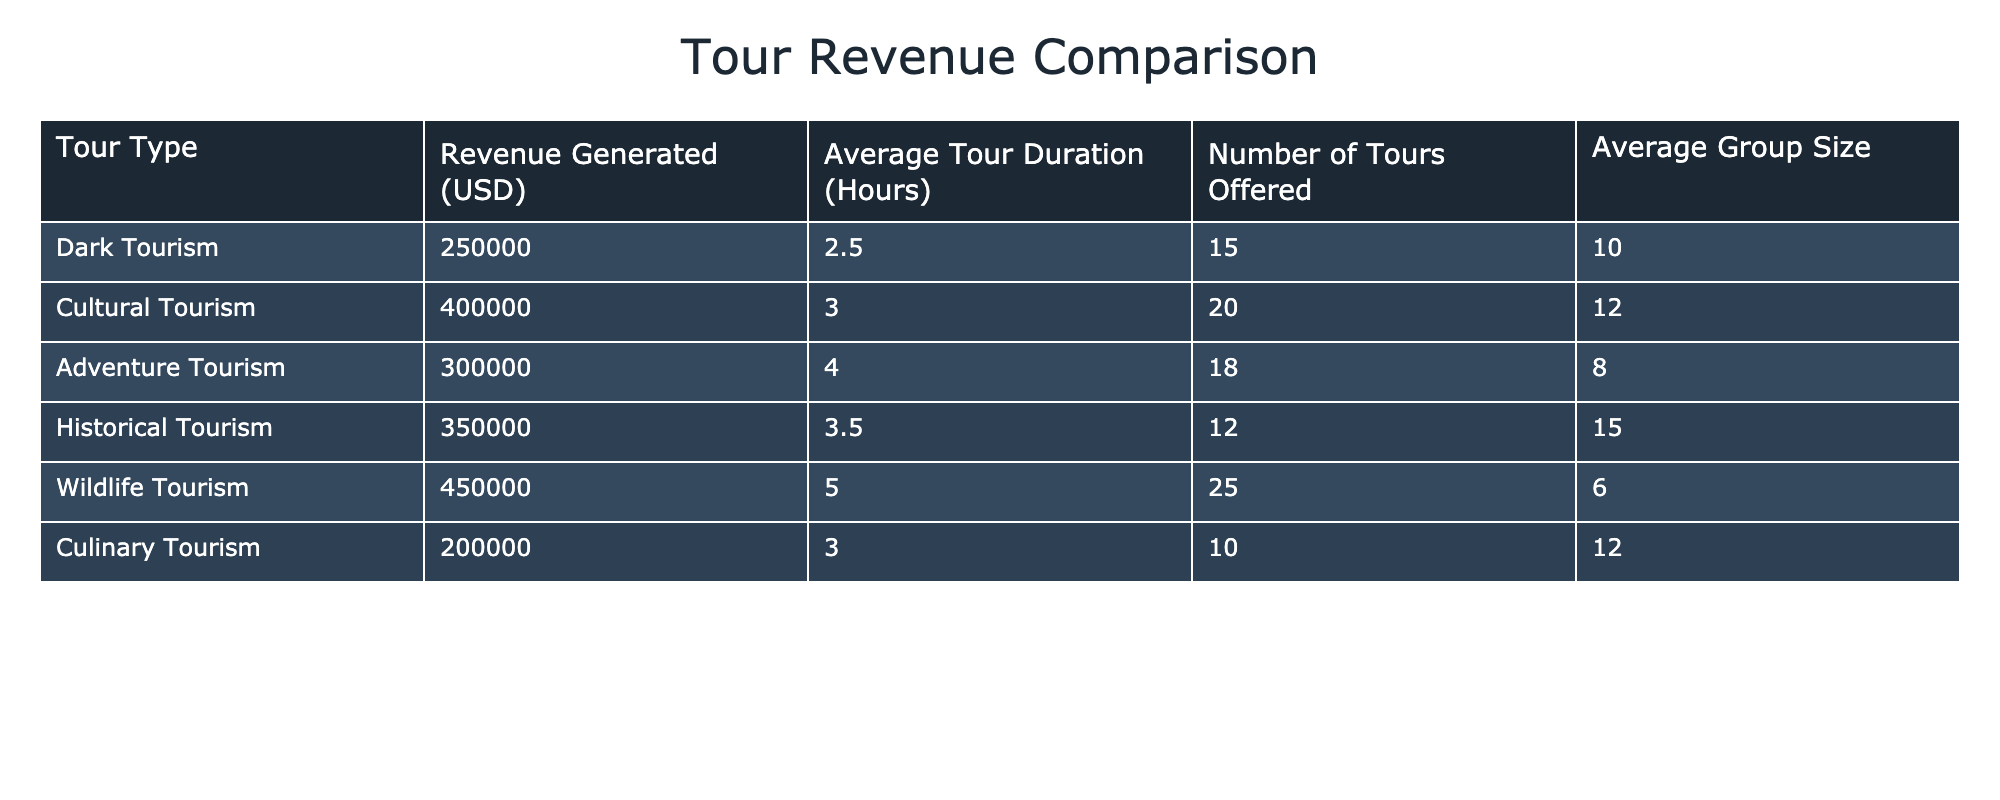What is the revenue generated from dark tourism tours? The table shows that the revenue generated from dark tourism tours is listed as 250000 USD.
Answer: 250000 USD How many tours are offered for cultural tourism? From the table, the number of tours offered for cultural tourism is clearly stated as 20.
Answer: 20 Which type of tourism has the highest average group size? By comparing the average group sizes from each type of tourism, historical tourism has the highest average group size at 15.
Answer: 15 What is the total revenue generated from adventure and culinary tourism combined? The revenue generated from adventure tourism is 300000 USD, and from culinary tourism is 200000 USD. Adding them together gives 300000 + 200000 = 500000 USD.
Answer: 500000 USD Is the average tour duration for dark tourism longer than that for culinary tourism? The average tour duration for dark tourism is 2.5 hours, and for culinary tourism, it is also 3.0 hours. Since 2.5 is not longer than 3.0, the answer is No.
Answer: No What is the average revenue generated per tour for historical tourism? The revenue for historical tourism is 350000 USD, and the number of tours offered is 12. To find the average revenue per tour, we divide 350000 by 12, which is approximately 29166.67 USD.
Answer: 29166.67 USD True or False: Wildlife tourism generates more revenue than adventure tourism. The revenue for wildlife tourism is 450000 USD, while for adventure tourism it is 300000 USD. Since 450000 is greater than 300000, the statement is True.
Answer: True Which type of tourism has the lowest revenue, and what is that amount? Among all tourism types, culinary tourism generates the least revenue at 200000 USD, making it the lowest.
Answer: 200000 USD What is the average revenue generated from all types of tourism listed? To find the average revenue, we first sum the revenues: 250000 + 400000 + 300000 + 350000 + 450000 + 200000 = 1950000 USD. Then, we divide by the number of tourism types, which is 6. Thus, the average revenue is 1950000 / 6 = 325000 USD.
Answer: 325000 USD 